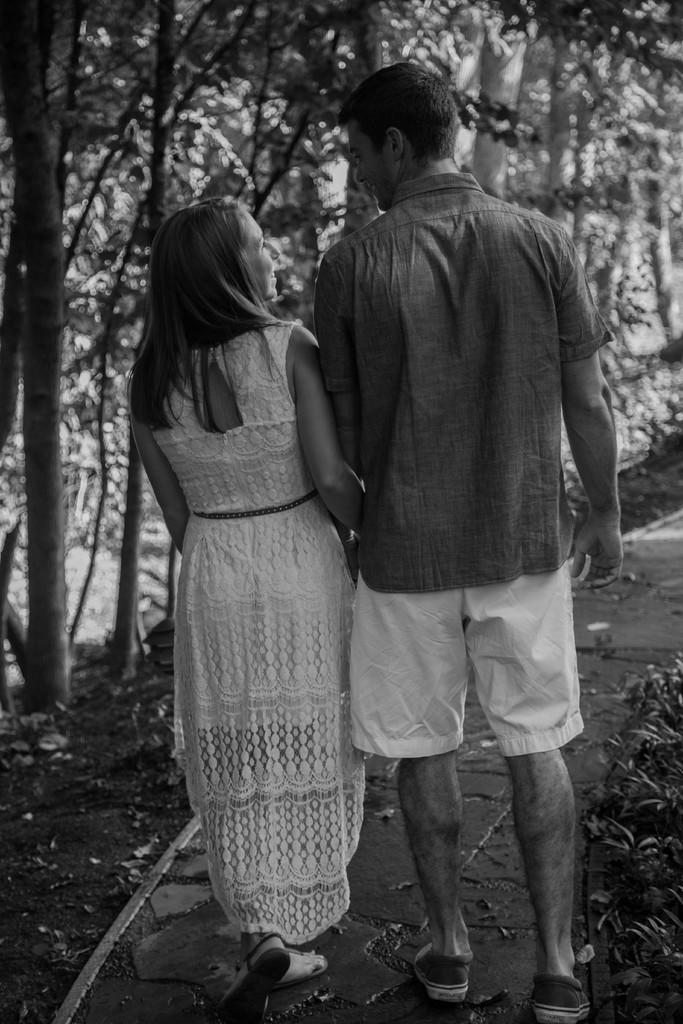What is the color scheme of the image? The image is black and white. Who can be seen in the image? There is a man and a woman in the image. What are the man and woman doing in the image? The man and woman are walking. What can be seen in the background of the image? There are many trees in the background of the image. Can you tell me how many ants are crawling on the man's arm in the image? There are no ants present in the image; it only features a man and a woman walking. What type of ray is swimming in the background of the image? There is no ray present in the image; the background consists of trees. 